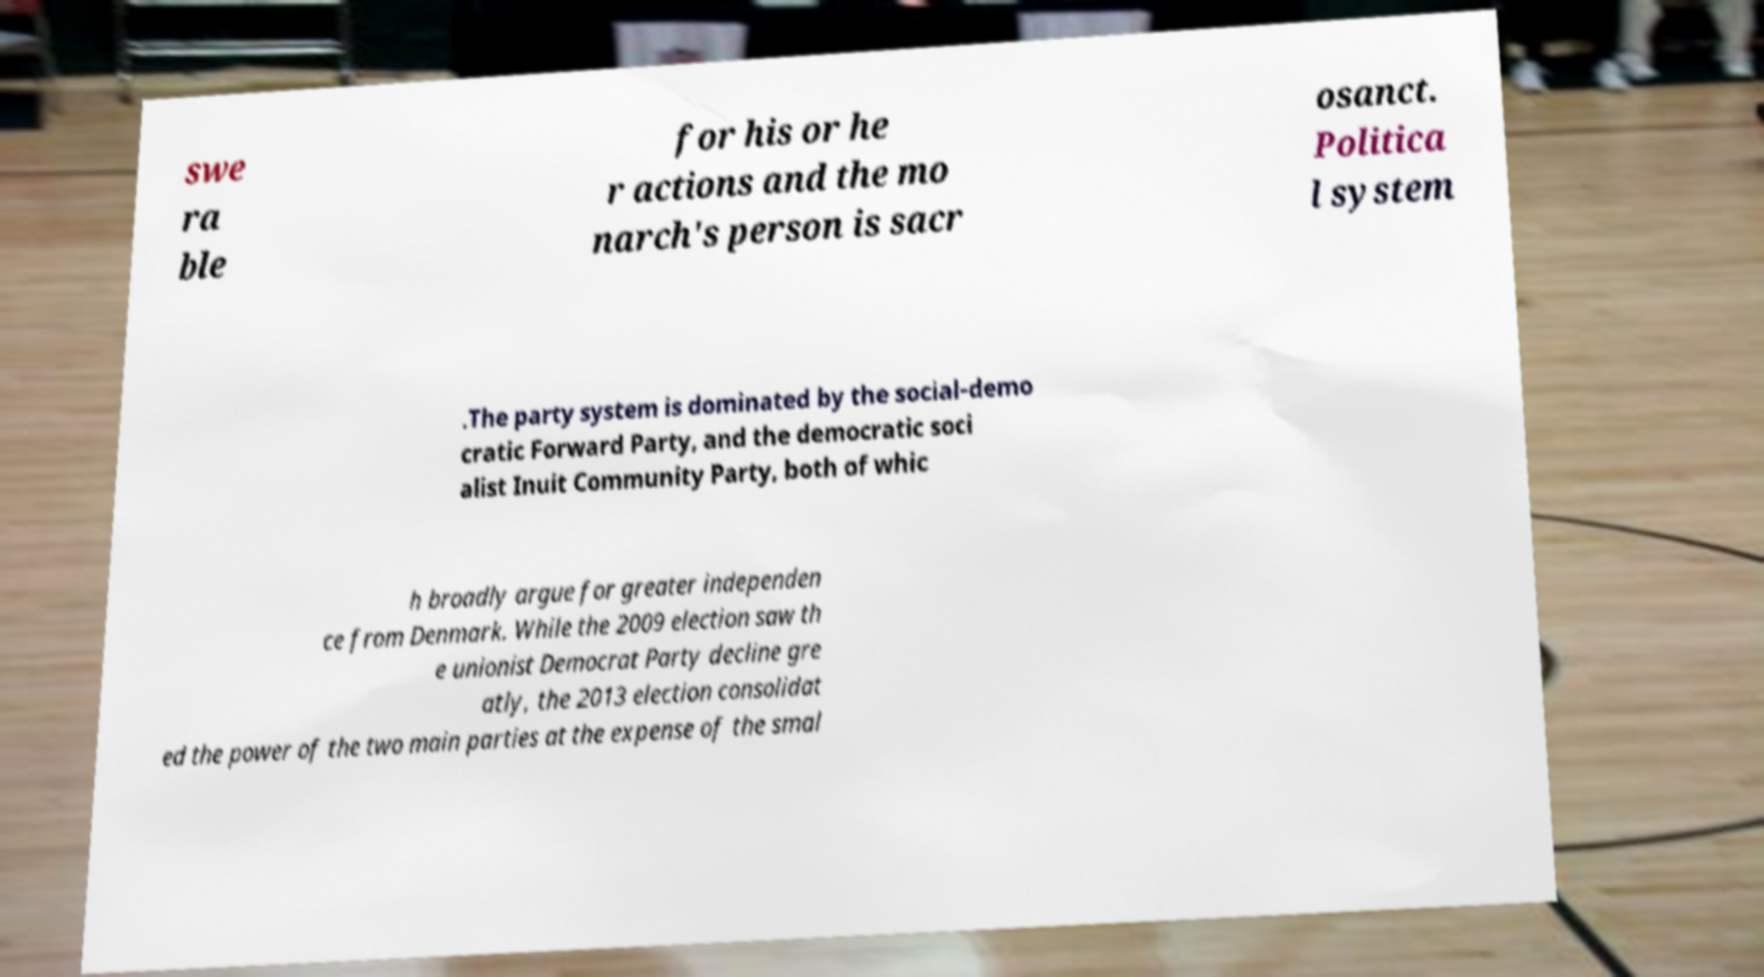For documentation purposes, I need the text within this image transcribed. Could you provide that? swe ra ble for his or he r actions and the mo narch's person is sacr osanct. Politica l system .The party system is dominated by the social-demo cratic Forward Party, and the democratic soci alist Inuit Community Party, both of whic h broadly argue for greater independen ce from Denmark. While the 2009 election saw th e unionist Democrat Party decline gre atly, the 2013 election consolidat ed the power of the two main parties at the expense of the smal 